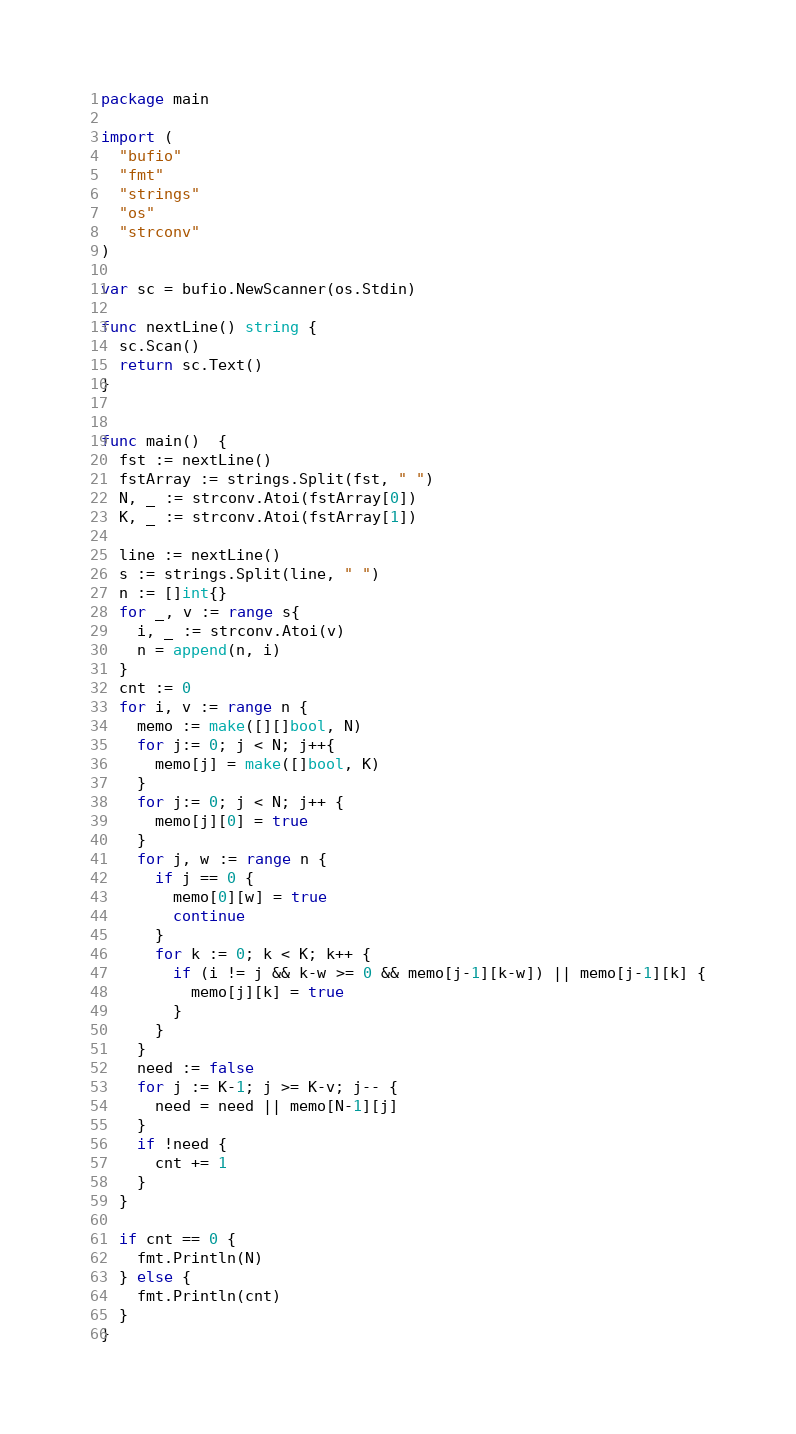<code> <loc_0><loc_0><loc_500><loc_500><_Go_>package main

import (
  "bufio"
  "fmt"
  "strings"
  "os"
  "strconv"
)

var sc = bufio.NewScanner(os.Stdin)

func nextLine() string {
  sc.Scan()
  return sc.Text()
}


func main()  {
  fst := nextLine()
  fstArray := strings.Split(fst, " ")
  N, _ := strconv.Atoi(fstArray[0])
  K, _ := strconv.Atoi(fstArray[1])

  line := nextLine()
  s := strings.Split(line, " ")
  n := []int{}
  for _, v := range s{
    i, _ := strconv.Atoi(v)
    n = append(n, i)
  }
  cnt := 0
  for i, v := range n {
    memo := make([][]bool, N)
    for j:= 0; j < N; j++{
      memo[j] = make([]bool, K)
    }
    for j:= 0; j < N; j++ {
      memo[j][0] = true
    }
    for j, w := range n {
      if j == 0 {
        memo[0][w] = true
        continue
      }
      for k := 0; k < K; k++ {
        if (i != j && k-w >= 0 && memo[j-1][k-w]) || memo[j-1][k] {
          memo[j][k] = true
        }
      }
    }
    need := false
    for j := K-1; j >= K-v; j-- {
      need = need || memo[N-1][j]
    }
    if !need {
      cnt += 1
    }
  }

  if cnt == 0 {
    fmt.Println(N)
  } else {
    fmt.Println(cnt)
  }
}
</code> 